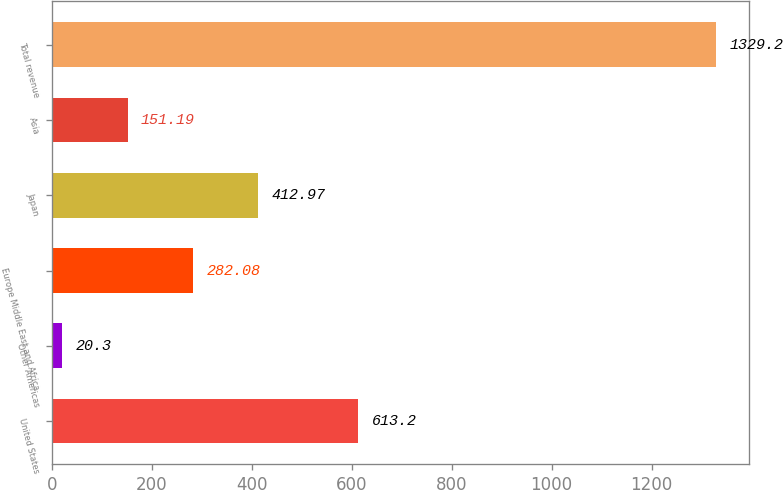Convert chart to OTSL. <chart><loc_0><loc_0><loc_500><loc_500><bar_chart><fcel>United States<fcel>Other Americas<fcel>Europe Middle East and Africa<fcel>Japan<fcel>Asia<fcel>Total revenue<nl><fcel>613.2<fcel>20.3<fcel>282.08<fcel>412.97<fcel>151.19<fcel>1329.2<nl></chart> 